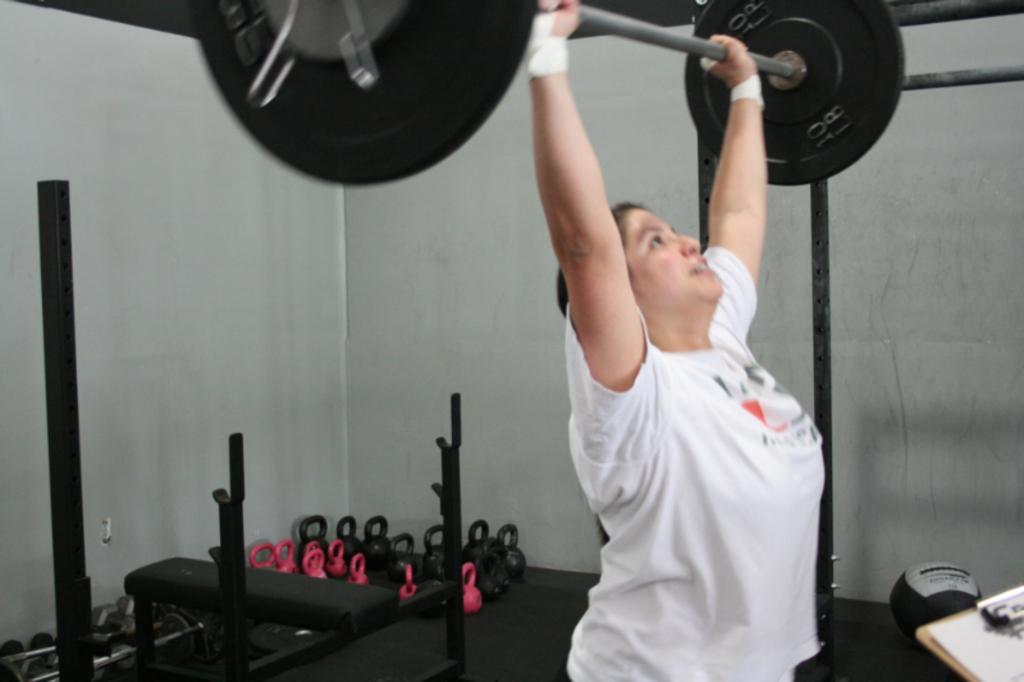Describe this image in one or two sentences. In this image we can see a woman lifting the weights with a rod. We can also see a bench, some poles, weights and a ball on the floor and a wall. At the bottom right we can see a paper on a pad. 